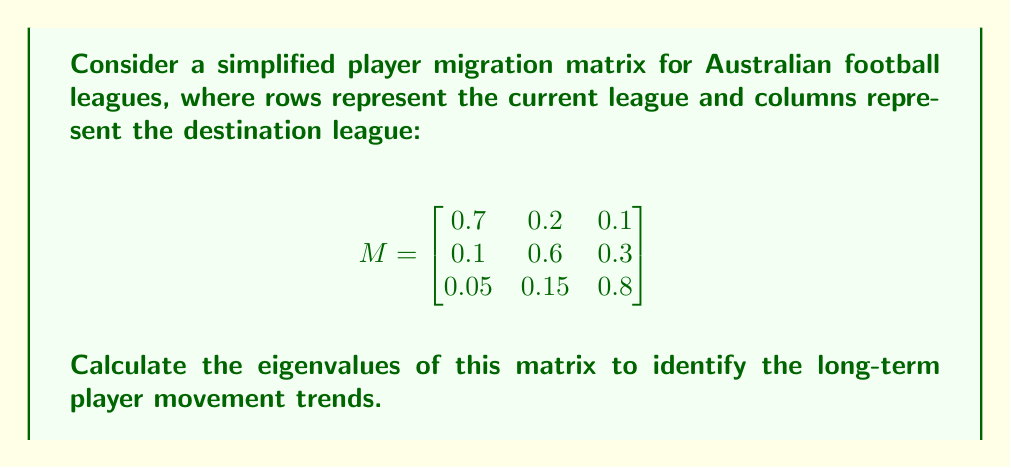Give your solution to this math problem. To find the eigenvalues of the migration matrix M, we need to solve the characteristic equation:

$$\det(M - \lambda I) = 0$$

Where $\lambda$ represents the eigenvalues and I is the 3x3 identity matrix.

Step 1: Set up the characteristic equation:

$$\det\begin{pmatrix}
0.7-\lambda & 0.2 & 0.1 \\
0.1 & 0.6-\lambda & 0.3 \\
0.05 & 0.15 & 0.8-\lambda
\end{pmatrix} = 0$$

Step 2: Expand the determinant:

$$(0.7-\lambda)[(0.6-\lambda)(0.8-\lambda) - 0.045] - 0.2[0.1(0.8-\lambda) - 0.015] + 0.1[0.1(0.15) - 0.05(0.6-\lambda)] = 0$$

Step 3: Simplify and collect terms:

$$-\lambda^3 + 2.1\lambda^2 - 1.435\lambda + 0.32 = 0$$

Step 4: Solve the cubic equation. This can be done using the cubic formula or numerical methods. Using a computer algebra system, we find the roots:

$$\lambda_1 \approx 1$$
$$\lambda_2 \approx 0.7$$
$$\lambda_3 \approx 0.4$$

The largest eigenvalue (1) represents the steady-state distribution of players across leagues. The other eigenvalues (0.7 and 0.4) indicate the rates at which the system approaches this steady state.
Answer: $\lambda_1 \approx 1, \lambda_2 \approx 0.7, \lambda_3 \approx 0.4$ 